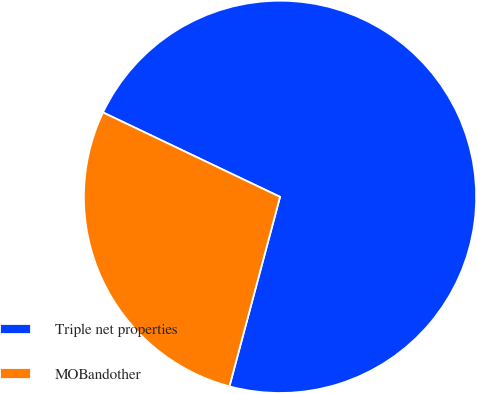Convert chart to OTSL. <chart><loc_0><loc_0><loc_500><loc_500><pie_chart><fcel>Triple net properties<fcel>MOBandother<nl><fcel>72.07%<fcel>27.93%<nl></chart> 